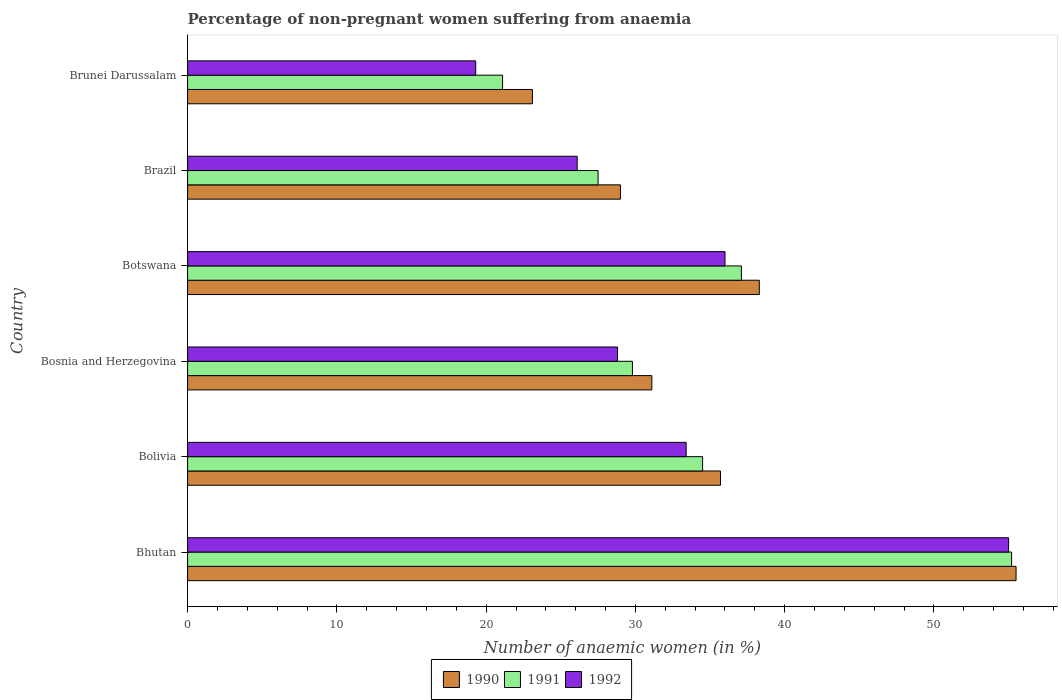How many different coloured bars are there?
Offer a very short reply. 3. How many groups of bars are there?
Give a very brief answer. 6. How many bars are there on the 4th tick from the top?
Make the answer very short. 3. What is the label of the 4th group of bars from the top?
Provide a succinct answer. Bosnia and Herzegovina. In how many cases, is the number of bars for a given country not equal to the number of legend labels?
Offer a terse response. 0. What is the percentage of non-pregnant women suffering from anaemia in 1990 in Bolivia?
Give a very brief answer. 35.7. Across all countries, what is the minimum percentage of non-pregnant women suffering from anaemia in 1991?
Your response must be concise. 21.1. In which country was the percentage of non-pregnant women suffering from anaemia in 1991 maximum?
Your answer should be compact. Bhutan. In which country was the percentage of non-pregnant women suffering from anaemia in 1992 minimum?
Offer a very short reply. Brunei Darussalam. What is the total percentage of non-pregnant women suffering from anaemia in 1991 in the graph?
Offer a very short reply. 205.2. What is the difference between the percentage of non-pregnant women suffering from anaemia in 1991 in Bosnia and Herzegovina and that in Botswana?
Your answer should be compact. -7.3. What is the difference between the percentage of non-pregnant women suffering from anaemia in 1990 in Bolivia and the percentage of non-pregnant women suffering from anaemia in 1992 in Botswana?
Your response must be concise. -0.3. What is the average percentage of non-pregnant women suffering from anaemia in 1992 per country?
Your answer should be very brief. 33.1. In how many countries, is the percentage of non-pregnant women suffering from anaemia in 1992 greater than 36 %?
Offer a terse response. 1. What is the ratio of the percentage of non-pregnant women suffering from anaemia in 1990 in Bhutan to that in Bosnia and Herzegovina?
Ensure brevity in your answer.  1.78. Is the percentage of non-pregnant women suffering from anaemia in 1990 in Bolivia less than that in Brunei Darussalam?
Offer a terse response. No. What is the difference between the highest and the second highest percentage of non-pregnant women suffering from anaemia in 1991?
Offer a terse response. 18.1. What is the difference between the highest and the lowest percentage of non-pregnant women suffering from anaemia in 1991?
Make the answer very short. 34.1. In how many countries, is the percentage of non-pregnant women suffering from anaemia in 1991 greater than the average percentage of non-pregnant women suffering from anaemia in 1991 taken over all countries?
Your answer should be very brief. 3. Is the sum of the percentage of non-pregnant women suffering from anaemia in 1990 in Bolivia and Brunei Darussalam greater than the maximum percentage of non-pregnant women suffering from anaemia in 1992 across all countries?
Your answer should be compact. Yes. What does the 1st bar from the bottom in Bolivia represents?
Provide a succinct answer. 1990. Is it the case that in every country, the sum of the percentage of non-pregnant women suffering from anaemia in 1990 and percentage of non-pregnant women suffering from anaemia in 1992 is greater than the percentage of non-pregnant women suffering from anaemia in 1991?
Provide a succinct answer. Yes. How many bars are there?
Your answer should be compact. 18. Are all the bars in the graph horizontal?
Ensure brevity in your answer.  Yes. Are the values on the major ticks of X-axis written in scientific E-notation?
Keep it short and to the point. No. Does the graph contain any zero values?
Your response must be concise. No. Does the graph contain grids?
Keep it short and to the point. No. Where does the legend appear in the graph?
Make the answer very short. Bottom center. How many legend labels are there?
Your answer should be very brief. 3. How are the legend labels stacked?
Your answer should be compact. Horizontal. What is the title of the graph?
Ensure brevity in your answer.  Percentage of non-pregnant women suffering from anaemia. Does "1975" appear as one of the legend labels in the graph?
Your answer should be very brief. No. What is the label or title of the X-axis?
Your answer should be very brief. Number of anaemic women (in %). What is the Number of anaemic women (in %) in 1990 in Bhutan?
Your response must be concise. 55.5. What is the Number of anaemic women (in %) in 1991 in Bhutan?
Your answer should be very brief. 55.2. What is the Number of anaemic women (in %) of 1990 in Bolivia?
Offer a terse response. 35.7. What is the Number of anaemic women (in %) in 1991 in Bolivia?
Offer a very short reply. 34.5. What is the Number of anaemic women (in %) in 1992 in Bolivia?
Offer a very short reply. 33.4. What is the Number of anaemic women (in %) in 1990 in Bosnia and Herzegovina?
Your answer should be very brief. 31.1. What is the Number of anaemic women (in %) in 1991 in Bosnia and Herzegovina?
Give a very brief answer. 29.8. What is the Number of anaemic women (in %) in 1992 in Bosnia and Herzegovina?
Ensure brevity in your answer.  28.8. What is the Number of anaemic women (in %) of 1990 in Botswana?
Make the answer very short. 38.3. What is the Number of anaemic women (in %) of 1991 in Botswana?
Your answer should be compact. 37.1. What is the Number of anaemic women (in %) of 1992 in Botswana?
Your response must be concise. 36. What is the Number of anaemic women (in %) in 1991 in Brazil?
Your answer should be compact. 27.5. What is the Number of anaemic women (in %) of 1992 in Brazil?
Your response must be concise. 26.1. What is the Number of anaemic women (in %) in 1990 in Brunei Darussalam?
Provide a succinct answer. 23.1. What is the Number of anaemic women (in %) of 1991 in Brunei Darussalam?
Your answer should be compact. 21.1. What is the Number of anaemic women (in %) of 1992 in Brunei Darussalam?
Your answer should be compact. 19.3. Across all countries, what is the maximum Number of anaemic women (in %) in 1990?
Make the answer very short. 55.5. Across all countries, what is the maximum Number of anaemic women (in %) in 1991?
Your answer should be very brief. 55.2. Across all countries, what is the minimum Number of anaemic women (in %) of 1990?
Provide a short and direct response. 23.1. Across all countries, what is the minimum Number of anaemic women (in %) in 1991?
Your response must be concise. 21.1. Across all countries, what is the minimum Number of anaemic women (in %) in 1992?
Your answer should be compact. 19.3. What is the total Number of anaemic women (in %) in 1990 in the graph?
Your answer should be compact. 212.7. What is the total Number of anaemic women (in %) of 1991 in the graph?
Offer a very short reply. 205.2. What is the total Number of anaemic women (in %) in 1992 in the graph?
Keep it short and to the point. 198.6. What is the difference between the Number of anaemic women (in %) in 1990 in Bhutan and that in Bolivia?
Your answer should be very brief. 19.8. What is the difference between the Number of anaemic women (in %) in 1991 in Bhutan and that in Bolivia?
Your response must be concise. 20.7. What is the difference between the Number of anaemic women (in %) of 1992 in Bhutan and that in Bolivia?
Make the answer very short. 21.6. What is the difference between the Number of anaemic women (in %) of 1990 in Bhutan and that in Bosnia and Herzegovina?
Provide a short and direct response. 24.4. What is the difference between the Number of anaemic women (in %) in 1991 in Bhutan and that in Bosnia and Herzegovina?
Give a very brief answer. 25.4. What is the difference between the Number of anaemic women (in %) in 1992 in Bhutan and that in Bosnia and Herzegovina?
Your answer should be compact. 26.2. What is the difference between the Number of anaemic women (in %) of 1991 in Bhutan and that in Botswana?
Ensure brevity in your answer.  18.1. What is the difference between the Number of anaemic women (in %) in 1990 in Bhutan and that in Brazil?
Provide a succinct answer. 26.5. What is the difference between the Number of anaemic women (in %) in 1991 in Bhutan and that in Brazil?
Offer a terse response. 27.7. What is the difference between the Number of anaemic women (in %) in 1992 in Bhutan and that in Brazil?
Give a very brief answer. 28.9. What is the difference between the Number of anaemic women (in %) in 1990 in Bhutan and that in Brunei Darussalam?
Ensure brevity in your answer.  32.4. What is the difference between the Number of anaemic women (in %) of 1991 in Bhutan and that in Brunei Darussalam?
Keep it short and to the point. 34.1. What is the difference between the Number of anaemic women (in %) of 1992 in Bhutan and that in Brunei Darussalam?
Your answer should be very brief. 35.7. What is the difference between the Number of anaemic women (in %) in 1991 in Bolivia and that in Bosnia and Herzegovina?
Offer a terse response. 4.7. What is the difference between the Number of anaemic women (in %) in 1991 in Bolivia and that in Brazil?
Your response must be concise. 7. What is the difference between the Number of anaemic women (in %) of 1990 in Bolivia and that in Brunei Darussalam?
Your answer should be compact. 12.6. What is the difference between the Number of anaemic women (in %) of 1991 in Bolivia and that in Brunei Darussalam?
Offer a terse response. 13.4. What is the difference between the Number of anaemic women (in %) of 1990 in Bosnia and Herzegovina and that in Botswana?
Provide a succinct answer. -7.2. What is the difference between the Number of anaemic women (in %) in 1991 in Bosnia and Herzegovina and that in Botswana?
Provide a short and direct response. -7.3. What is the difference between the Number of anaemic women (in %) of 1990 in Bosnia and Herzegovina and that in Brazil?
Provide a succinct answer. 2.1. What is the difference between the Number of anaemic women (in %) of 1990 in Bosnia and Herzegovina and that in Brunei Darussalam?
Keep it short and to the point. 8. What is the difference between the Number of anaemic women (in %) of 1991 in Bosnia and Herzegovina and that in Brunei Darussalam?
Ensure brevity in your answer.  8.7. What is the difference between the Number of anaemic women (in %) of 1992 in Bosnia and Herzegovina and that in Brunei Darussalam?
Give a very brief answer. 9.5. What is the difference between the Number of anaemic women (in %) in 1990 in Botswana and that in Brazil?
Your answer should be very brief. 9.3. What is the difference between the Number of anaemic women (in %) in 1991 in Botswana and that in Brazil?
Make the answer very short. 9.6. What is the difference between the Number of anaemic women (in %) in 1992 in Botswana and that in Brazil?
Provide a short and direct response. 9.9. What is the difference between the Number of anaemic women (in %) in 1991 in Botswana and that in Brunei Darussalam?
Provide a succinct answer. 16. What is the difference between the Number of anaemic women (in %) in 1992 in Botswana and that in Brunei Darussalam?
Your answer should be compact. 16.7. What is the difference between the Number of anaemic women (in %) in 1991 in Brazil and that in Brunei Darussalam?
Offer a terse response. 6.4. What is the difference between the Number of anaemic women (in %) of 1990 in Bhutan and the Number of anaemic women (in %) of 1991 in Bolivia?
Give a very brief answer. 21. What is the difference between the Number of anaemic women (in %) of 1990 in Bhutan and the Number of anaemic women (in %) of 1992 in Bolivia?
Give a very brief answer. 22.1. What is the difference between the Number of anaemic women (in %) in 1991 in Bhutan and the Number of anaemic women (in %) in 1992 in Bolivia?
Provide a succinct answer. 21.8. What is the difference between the Number of anaemic women (in %) in 1990 in Bhutan and the Number of anaemic women (in %) in 1991 in Bosnia and Herzegovina?
Provide a succinct answer. 25.7. What is the difference between the Number of anaemic women (in %) in 1990 in Bhutan and the Number of anaemic women (in %) in 1992 in Bosnia and Herzegovina?
Ensure brevity in your answer.  26.7. What is the difference between the Number of anaemic women (in %) in 1991 in Bhutan and the Number of anaemic women (in %) in 1992 in Bosnia and Herzegovina?
Provide a succinct answer. 26.4. What is the difference between the Number of anaemic women (in %) of 1990 in Bhutan and the Number of anaemic women (in %) of 1991 in Brazil?
Provide a short and direct response. 28. What is the difference between the Number of anaemic women (in %) in 1990 in Bhutan and the Number of anaemic women (in %) in 1992 in Brazil?
Ensure brevity in your answer.  29.4. What is the difference between the Number of anaemic women (in %) of 1991 in Bhutan and the Number of anaemic women (in %) of 1992 in Brazil?
Keep it short and to the point. 29.1. What is the difference between the Number of anaemic women (in %) in 1990 in Bhutan and the Number of anaemic women (in %) in 1991 in Brunei Darussalam?
Ensure brevity in your answer.  34.4. What is the difference between the Number of anaemic women (in %) of 1990 in Bhutan and the Number of anaemic women (in %) of 1992 in Brunei Darussalam?
Provide a succinct answer. 36.2. What is the difference between the Number of anaemic women (in %) in 1991 in Bhutan and the Number of anaemic women (in %) in 1992 in Brunei Darussalam?
Your answer should be very brief. 35.9. What is the difference between the Number of anaemic women (in %) in 1990 in Bolivia and the Number of anaemic women (in %) in 1991 in Bosnia and Herzegovina?
Ensure brevity in your answer.  5.9. What is the difference between the Number of anaemic women (in %) of 1990 in Bolivia and the Number of anaemic women (in %) of 1991 in Botswana?
Your answer should be very brief. -1.4. What is the difference between the Number of anaemic women (in %) of 1990 in Bolivia and the Number of anaemic women (in %) of 1992 in Botswana?
Provide a short and direct response. -0.3. What is the difference between the Number of anaemic women (in %) of 1990 in Bolivia and the Number of anaemic women (in %) of 1991 in Brazil?
Provide a succinct answer. 8.2. What is the difference between the Number of anaemic women (in %) of 1990 in Bolivia and the Number of anaemic women (in %) of 1991 in Brunei Darussalam?
Make the answer very short. 14.6. What is the difference between the Number of anaemic women (in %) of 1990 in Bolivia and the Number of anaemic women (in %) of 1992 in Brunei Darussalam?
Your response must be concise. 16.4. What is the difference between the Number of anaemic women (in %) in 1991 in Bolivia and the Number of anaemic women (in %) in 1992 in Brunei Darussalam?
Give a very brief answer. 15.2. What is the difference between the Number of anaemic women (in %) of 1990 in Bosnia and Herzegovina and the Number of anaemic women (in %) of 1991 in Botswana?
Offer a very short reply. -6. What is the difference between the Number of anaemic women (in %) in 1991 in Bosnia and Herzegovina and the Number of anaemic women (in %) in 1992 in Botswana?
Provide a short and direct response. -6.2. What is the difference between the Number of anaemic women (in %) of 1990 in Bosnia and Herzegovina and the Number of anaemic women (in %) of 1991 in Brazil?
Ensure brevity in your answer.  3.6. What is the difference between the Number of anaemic women (in %) of 1990 in Bosnia and Herzegovina and the Number of anaemic women (in %) of 1991 in Brunei Darussalam?
Ensure brevity in your answer.  10. What is the difference between the Number of anaemic women (in %) of 1990 in Bosnia and Herzegovina and the Number of anaemic women (in %) of 1992 in Brunei Darussalam?
Make the answer very short. 11.8. What is the difference between the Number of anaemic women (in %) in 1991 in Bosnia and Herzegovina and the Number of anaemic women (in %) in 1992 in Brunei Darussalam?
Your response must be concise. 10.5. What is the difference between the Number of anaemic women (in %) in 1990 in Botswana and the Number of anaemic women (in %) in 1991 in Brazil?
Keep it short and to the point. 10.8. What is the difference between the Number of anaemic women (in %) of 1990 in Botswana and the Number of anaemic women (in %) of 1992 in Brazil?
Provide a short and direct response. 12.2. What is the difference between the Number of anaemic women (in %) in 1990 in Botswana and the Number of anaemic women (in %) in 1991 in Brunei Darussalam?
Keep it short and to the point. 17.2. What is the difference between the Number of anaemic women (in %) in 1991 in Botswana and the Number of anaemic women (in %) in 1992 in Brunei Darussalam?
Provide a short and direct response. 17.8. What is the difference between the Number of anaemic women (in %) of 1990 in Brazil and the Number of anaemic women (in %) of 1991 in Brunei Darussalam?
Keep it short and to the point. 7.9. What is the difference between the Number of anaemic women (in %) in 1991 in Brazil and the Number of anaemic women (in %) in 1992 in Brunei Darussalam?
Offer a terse response. 8.2. What is the average Number of anaemic women (in %) in 1990 per country?
Provide a short and direct response. 35.45. What is the average Number of anaemic women (in %) of 1991 per country?
Your answer should be compact. 34.2. What is the average Number of anaemic women (in %) of 1992 per country?
Make the answer very short. 33.1. What is the difference between the Number of anaemic women (in %) of 1990 and Number of anaemic women (in %) of 1991 in Bhutan?
Ensure brevity in your answer.  0.3. What is the difference between the Number of anaemic women (in %) of 1990 and Number of anaemic women (in %) of 1992 in Bhutan?
Keep it short and to the point. 0.5. What is the difference between the Number of anaemic women (in %) in 1991 and Number of anaemic women (in %) in 1992 in Bhutan?
Give a very brief answer. 0.2. What is the difference between the Number of anaemic women (in %) of 1990 and Number of anaemic women (in %) of 1992 in Bolivia?
Ensure brevity in your answer.  2.3. What is the difference between the Number of anaemic women (in %) of 1990 and Number of anaemic women (in %) of 1992 in Botswana?
Offer a very short reply. 2.3. What is the difference between the Number of anaemic women (in %) of 1990 and Number of anaemic women (in %) of 1991 in Brazil?
Keep it short and to the point. 1.5. What is the difference between the Number of anaemic women (in %) of 1990 and Number of anaemic women (in %) of 1992 in Brazil?
Provide a succinct answer. 2.9. What is the difference between the Number of anaemic women (in %) of 1991 and Number of anaemic women (in %) of 1992 in Brazil?
Offer a very short reply. 1.4. What is the difference between the Number of anaemic women (in %) of 1990 and Number of anaemic women (in %) of 1991 in Brunei Darussalam?
Offer a terse response. 2. What is the difference between the Number of anaemic women (in %) of 1990 and Number of anaemic women (in %) of 1992 in Brunei Darussalam?
Your answer should be compact. 3.8. What is the difference between the Number of anaemic women (in %) in 1991 and Number of anaemic women (in %) in 1992 in Brunei Darussalam?
Ensure brevity in your answer.  1.8. What is the ratio of the Number of anaemic women (in %) in 1990 in Bhutan to that in Bolivia?
Your response must be concise. 1.55. What is the ratio of the Number of anaemic women (in %) in 1992 in Bhutan to that in Bolivia?
Your answer should be very brief. 1.65. What is the ratio of the Number of anaemic women (in %) in 1990 in Bhutan to that in Bosnia and Herzegovina?
Make the answer very short. 1.78. What is the ratio of the Number of anaemic women (in %) in 1991 in Bhutan to that in Bosnia and Herzegovina?
Ensure brevity in your answer.  1.85. What is the ratio of the Number of anaemic women (in %) of 1992 in Bhutan to that in Bosnia and Herzegovina?
Keep it short and to the point. 1.91. What is the ratio of the Number of anaemic women (in %) of 1990 in Bhutan to that in Botswana?
Ensure brevity in your answer.  1.45. What is the ratio of the Number of anaemic women (in %) in 1991 in Bhutan to that in Botswana?
Make the answer very short. 1.49. What is the ratio of the Number of anaemic women (in %) of 1992 in Bhutan to that in Botswana?
Keep it short and to the point. 1.53. What is the ratio of the Number of anaemic women (in %) of 1990 in Bhutan to that in Brazil?
Ensure brevity in your answer.  1.91. What is the ratio of the Number of anaemic women (in %) of 1991 in Bhutan to that in Brazil?
Offer a terse response. 2.01. What is the ratio of the Number of anaemic women (in %) of 1992 in Bhutan to that in Brazil?
Offer a terse response. 2.11. What is the ratio of the Number of anaemic women (in %) of 1990 in Bhutan to that in Brunei Darussalam?
Your answer should be very brief. 2.4. What is the ratio of the Number of anaemic women (in %) in 1991 in Bhutan to that in Brunei Darussalam?
Make the answer very short. 2.62. What is the ratio of the Number of anaemic women (in %) in 1992 in Bhutan to that in Brunei Darussalam?
Offer a very short reply. 2.85. What is the ratio of the Number of anaemic women (in %) of 1990 in Bolivia to that in Bosnia and Herzegovina?
Your answer should be compact. 1.15. What is the ratio of the Number of anaemic women (in %) in 1991 in Bolivia to that in Bosnia and Herzegovina?
Give a very brief answer. 1.16. What is the ratio of the Number of anaemic women (in %) in 1992 in Bolivia to that in Bosnia and Herzegovina?
Offer a terse response. 1.16. What is the ratio of the Number of anaemic women (in %) of 1990 in Bolivia to that in Botswana?
Provide a short and direct response. 0.93. What is the ratio of the Number of anaemic women (in %) in 1991 in Bolivia to that in Botswana?
Keep it short and to the point. 0.93. What is the ratio of the Number of anaemic women (in %) in 1992 in Bolivia to that in Botswana?
Provide a succinct answer. 0.93. What is the ratio of the Number of anaemic women (in %) of 1990 in Bolivia to that in Brazil?
Your response must be concise. 1.23. What is the ratio of the Number of anaemic women (in %) in 1991 in Bolivia to that in Brazil?
Offer a terse response. 1.25. What is the ratio of the Number of anaemic women (in %) in 1992 in Bolivia to that in Brazil?
Your answer should be compact. 1.28. What is the ratio of the Number of anaemic women (in %) of 1990 in Bolivia to that in Brunei Darussalam?
Give a very brief answer. 1.55. What is the ratio of the Number of anaemic women (in %) in 1991 in Bolivia to that in Brunei Darussalam?
Keep it short and to the point. 1.64. What is the ratio of the Number of anaemic women (in %) in 1992 in Bolivia to that in Brunei Darussalam?
Your answer should be very brief. 1.73. What is the ratio of the Number of anaemic women (in %) in 1990 in Bosnia and Herzegovina to that in Botswana?
Provide a succinct answer. 0.81. What is the ratio of the Number of anaemic women (in %) of 1991 in Bosnia and Herzegovina to that in Botswana?
Your answer should be compact. 0.8. What is the ratio of the Number of anaemic women (in %) of 1992 in Bosnia and Herzegovina to that in Botswana?
Offer a very short reply. 0.8. What is the ratio of the Number of anaemic women (in %) in 1990 in Bosnia and Herzegovina to that in Brazil?
Offer a terse response. 1.07. What is the ratio of the Number of anaemic women (in %) of 1991 in Bosnia and Herzegovina to that in Brazil?
Keep it short and to the point. 1.08. What is the ratio of the Number of anaemic women (in %) in 1992 in Bosnia and Herzegovina to that in Brazil?
Give a very brief answer. 1.1. What is the ratio of the Number of anaemic women (in %) in 1990 in Bosnia and Herzegovina to that in Brunei Darussalam?
Make the answer very short. 1.35. What is the ratio of the Number of anaemic women (in %) in 1991 in Bosnia and Herzegovina to that in Brunei Darussalam?
Give a very brief answer. 1.41. What is the ratio of the Number of anaemic women (in %) in 1992 in Bosnia and Herzegovina to that in Brunei Darussalam?
Ensure brevity in your answer.  1.49. What is the ratio of the Number of anaemic women (in %) of 1990 in Botswana to that in Brazil?
Give a very brief answer. 1.32. What is the ratio of the Number of anaemic women (in %) of 1991 in Botswana to that in Brazil?
Keep it short and to the point. 1.35. What is the ratio of the Number of anaemic women (in %) in 1992 in Botswana to that in Brazil?
Keep it short and to the point. 1.38. What is the ratio of the Number of anaemic women (in %) in 1990 in Botswana to that in Brunei Darussalam?
Provide a succinct answer. 1.66. What is the ratio of the Number of anaemic women (in %) in 1991 in Botswana to that in Brunei Darussalam?
Provide a short and direct response. 1.76. What is the ratio of the Number of anaemic women (in %) in 1992 in Botswana to that in Brunei Darussalam?
Offer a very short reply. 1.87. What is the ratio of the Number of anaemic women (in %) of 1990 in Brazil to that in Brunei Darussalam?
Your response must be concise. 1.26. What is the ratio of the Number of anaemic women (in %) of 1991 in Brazil to that in Brunei Darussalam?
Your response must be concise. 1.3. What is the ratio of the Number of anaemic women (in %) in 1992 in Brazil to that in Brunei Darussalam?
Your answer should be very brief. 1.35. What is the difference between the highest and the second highest Number of anaemic women (in %) in 1992?
Make the answer very short. 19. What is the difference between the highest and the lowest Number of anaemic women (in %) of 1990?
Ensure brevity in your answer.  32.4. What is the difference between the highest and the lowest Number of anaemic women (in %) in 1991?
Offer a very short reply. 34.1. What is the difference between the highest and the lowest Number of anaemic women (in %) of 1992?
Ensure brevity in your answer.  35.7. 